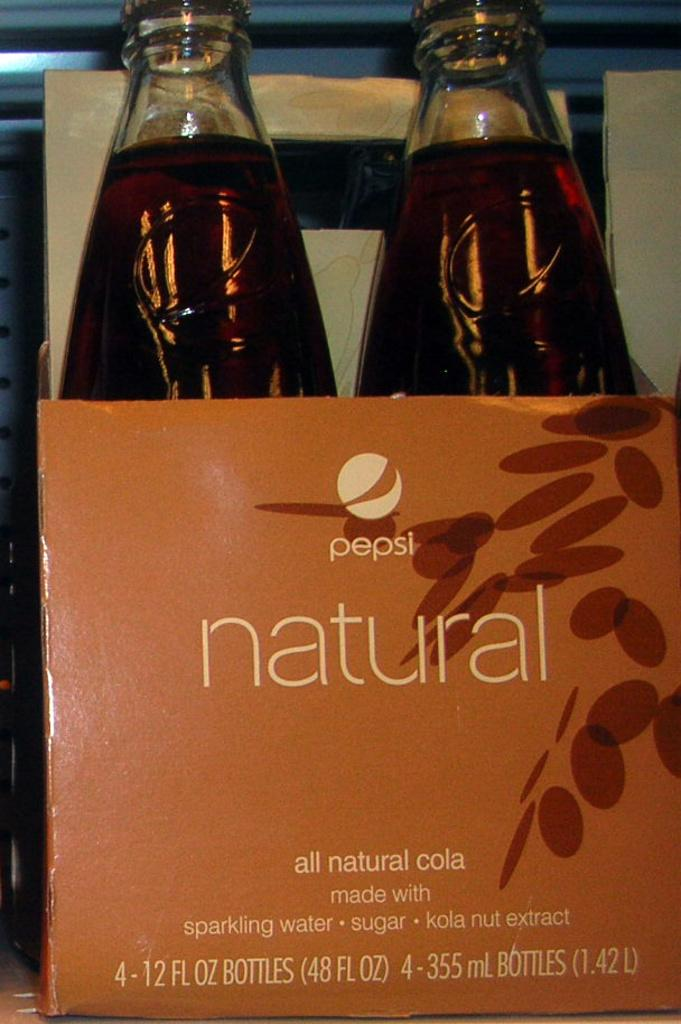How many bottles are visible in the image? There are two bottles in the image. Where are the bottles located in the image? The bottles are in a box. What is the name of the goose that is sitting on top of the box in the image? There is no goose present in the image; it only features two bottles in a box. 